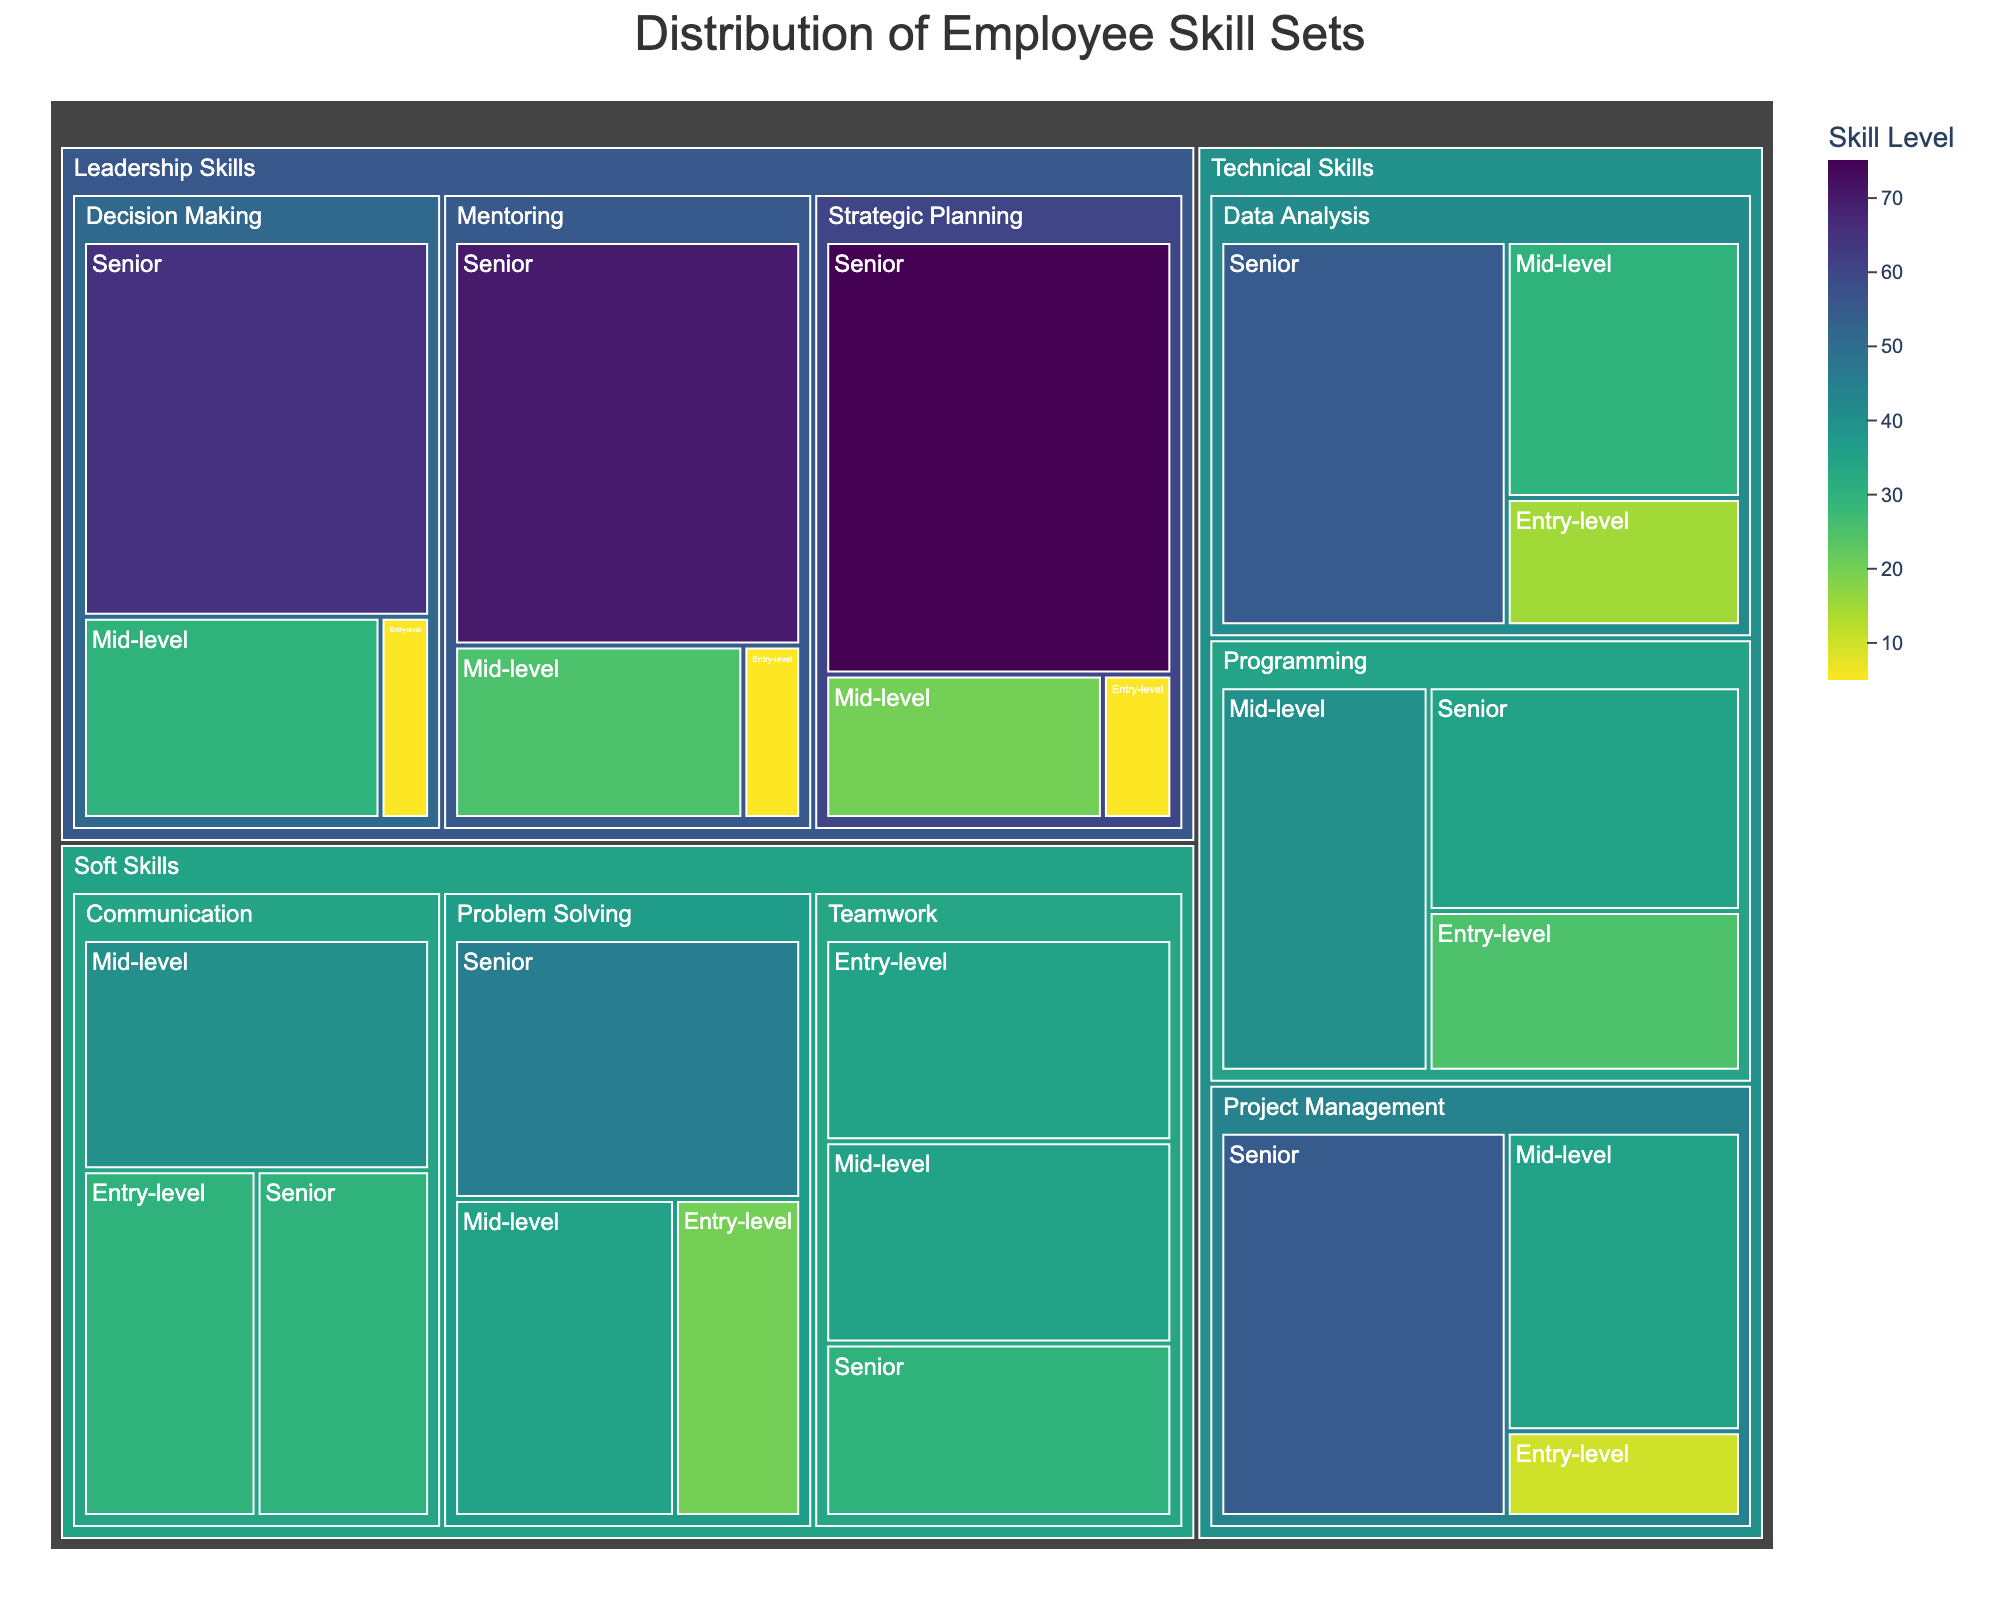What's the title of the Treemap? The title is usually displayed prominently at the top of a plot, it's a textual element meant to describe the overall content being visualized.
Answer: Distribution of Employee Skill Sets What are the different skill categories shown? The skill categories are the high-level sections within the Treemap, typically displayed as the largest containers in the hierarchy.
Answer: Technical Skills, Soft Skills, Leadership Skills Which skill subcategory has the highest value for Senior employees? To find this, look within each skill category, then identify the subcategory with the highest numerical value for the Senior level. The highest value is 75 under "Leadership Skills -> Strategic Planning."
Answer: Strategic Planning How many Mid-level employees have Programming skills? Navigate to "Technical Skills -> Programming" and identify the value associated with Mid-level, which is displayed directly within the corresponding section.
Answer: 40 What is the total number of employees with any Decision Making skills? Sum the values listed under "Leadership Skills -> Decision Making" for Entry-level, Mid-level, and Senior levels. The values are 5, 30, and 65, respectively.
Answer: 100 Compare the number of Entry-level employees with Communication skills to those with Mentoring skills. Which is higher? Look at the values under "Soft Skills -> Communication" and "Leadership Skills -> Mentoring" for Entry-level. Communication has 30, while Mentoring has 5.
Answer: Communication Which skill category has the least number of Entry-level employees? Check the values for Entry-level within each skill category and find the smallest number. "Leadership Skills" has the smallest values, each being 5.
Answer: Leadership Skills What's the average number of Senior employees with skills in Technical Skills? Determine the Senior values in Technical Skills (Programming: 35, Data Analysis: 55, Project Management: 55) and calculate the average: (35+55+55)/3.
Answer: 48.33 Is there more Mid-level or Senior-level employees with Data Analysis skills? Compare the values for Mid-level and Senior under "Technical Skills -> Data Analysis." Mid-level has 30, and Senior has 55.
Answer: Senior Which subcategory under Soft Skills has the least number of employees at any level? Identify the smallest value within Soft Skills by examining all values for each subcategory. "Problem Solving" has the smallest value, 20 for Entry-level.
Answer: Problem Solving (Entry-level) 